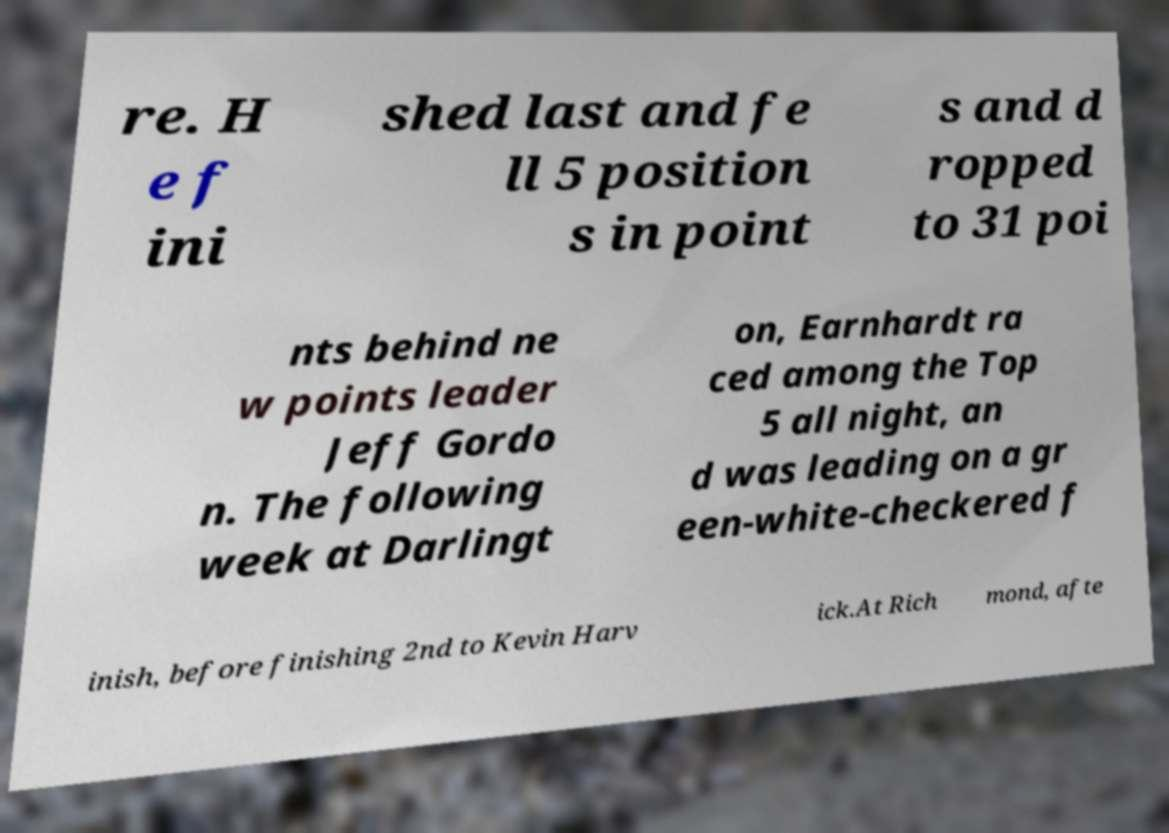Can you accurately transcribe the text from the provided image for me? re. H e f ini shed last and fe ll 5 position s in point s and d ropped to 31 poi nts behind ne w points leader Jeff Gordo n. The following week at Darlingt on, Earnhardt ra ced among the Top 5 all night, an d was leading on a gr een-white-checkered f inish, before finishing 2nd to Kevin Harv ick.At Rich mond, afte 